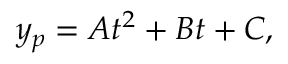Convert formula to latex. <formula><loc_0><loc_0><loc_500><loc_500>y _ { p } = A t ^ { 2 } + B t + C ,</formula> 